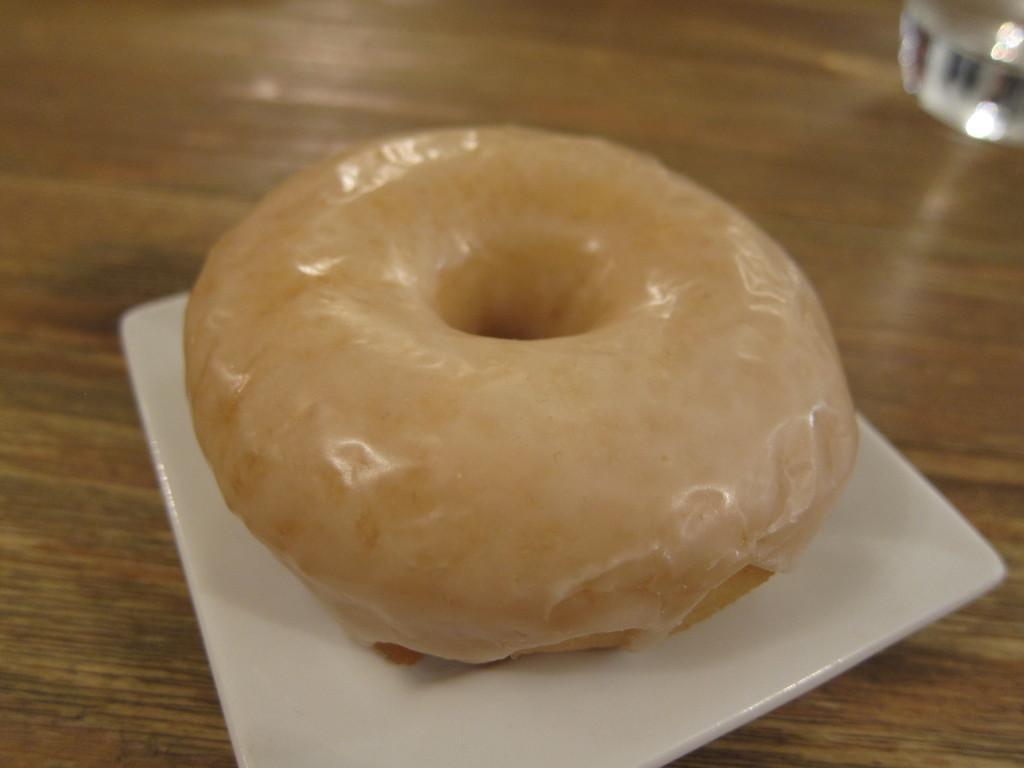Can you describe this image briefly? In this image I can see the food in the plate and the plate is in white color and the plate is on the brown color surface. 